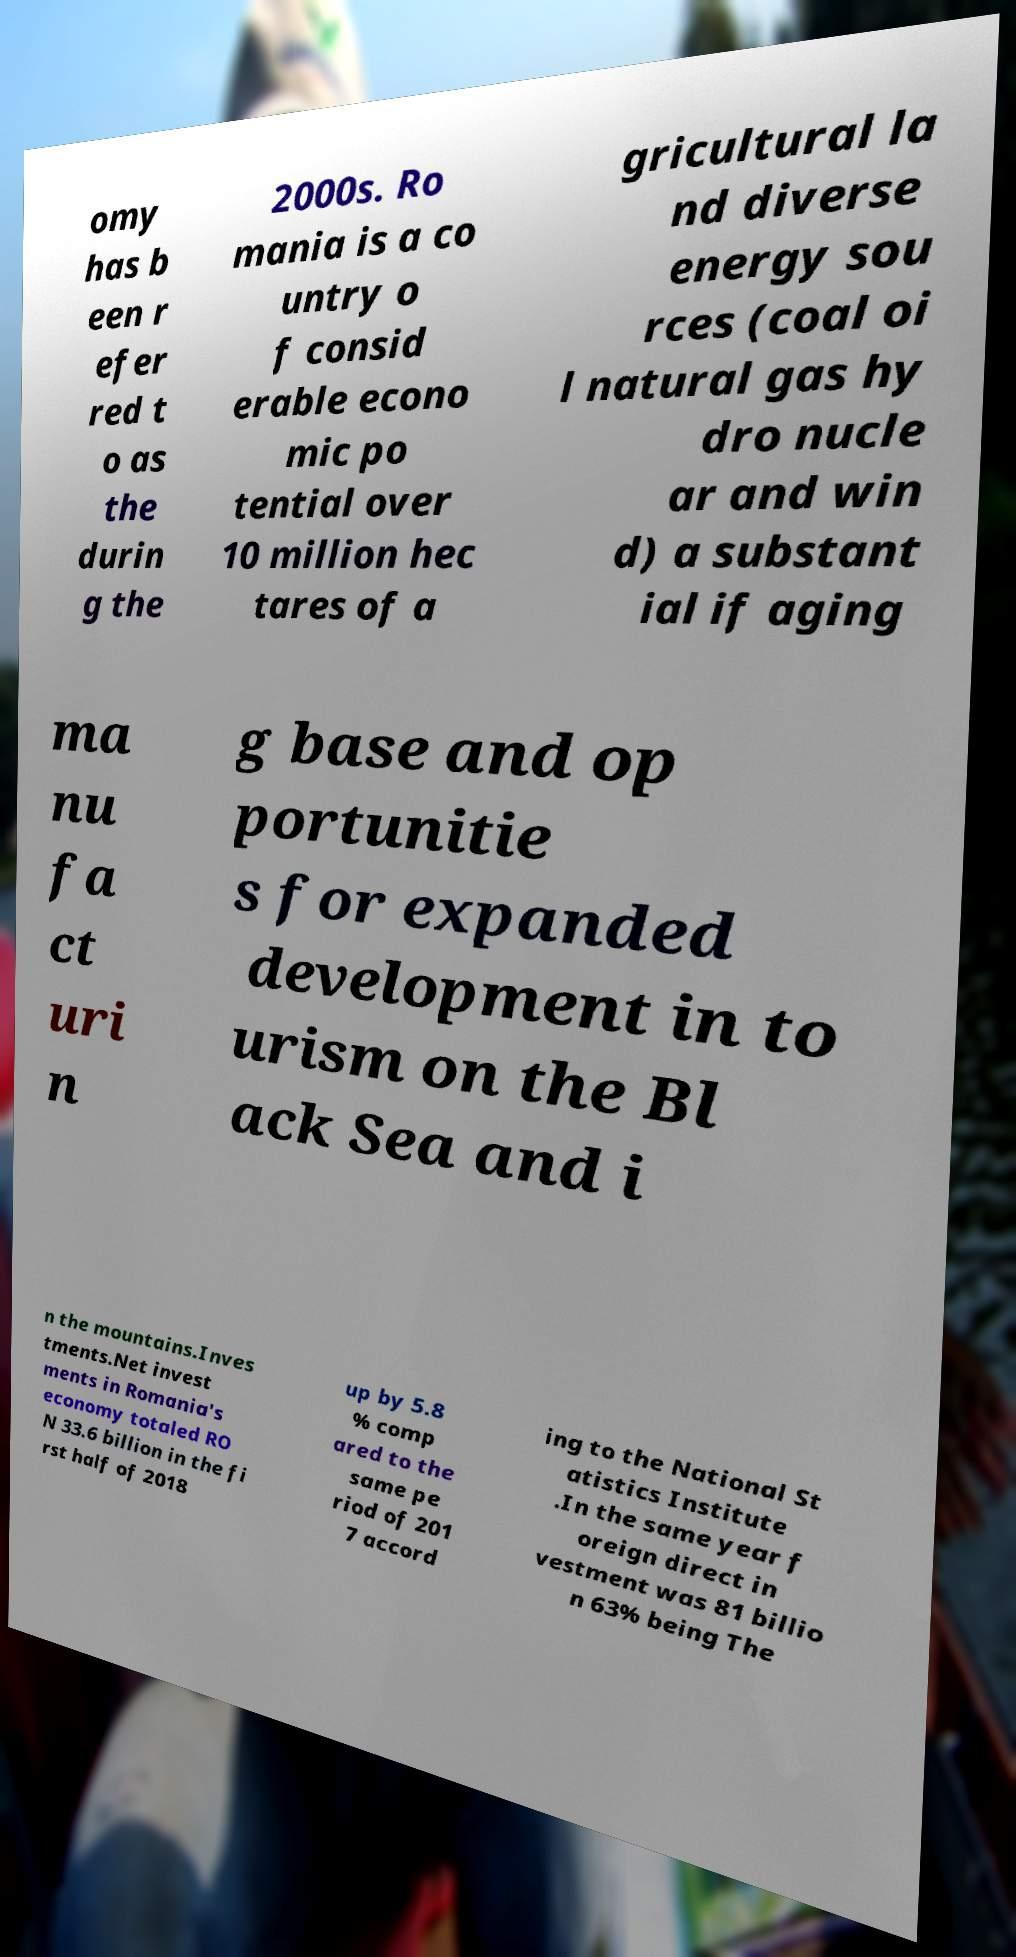What messages or text are displayed in this image? I need them in a readable, typed format. omy has b een r efer red t o as the durin g the 2000s. Ro mania is a co untry o f consid erable econo mic po tential over 10 million hec tares of a gricultural la nd diverse energy sou rces (coal oi l natural gas hy dro nucle ar and win d) a substant ial if aging ma nu fa ct uri n g base and op portunitie s for expanded development in to urism on the Bl ack Sea and i n the mountains.Inves tments.Net invest ments in Romania's economy totaled RO N 33.6 billion in the fi rst half of 2018 up by 5.8 % comp ared to the same pe riod of 201 7 accord ing to the National St atistics Institute .In the same year f oreign direct in vestment was 81 billio n 63% being The 